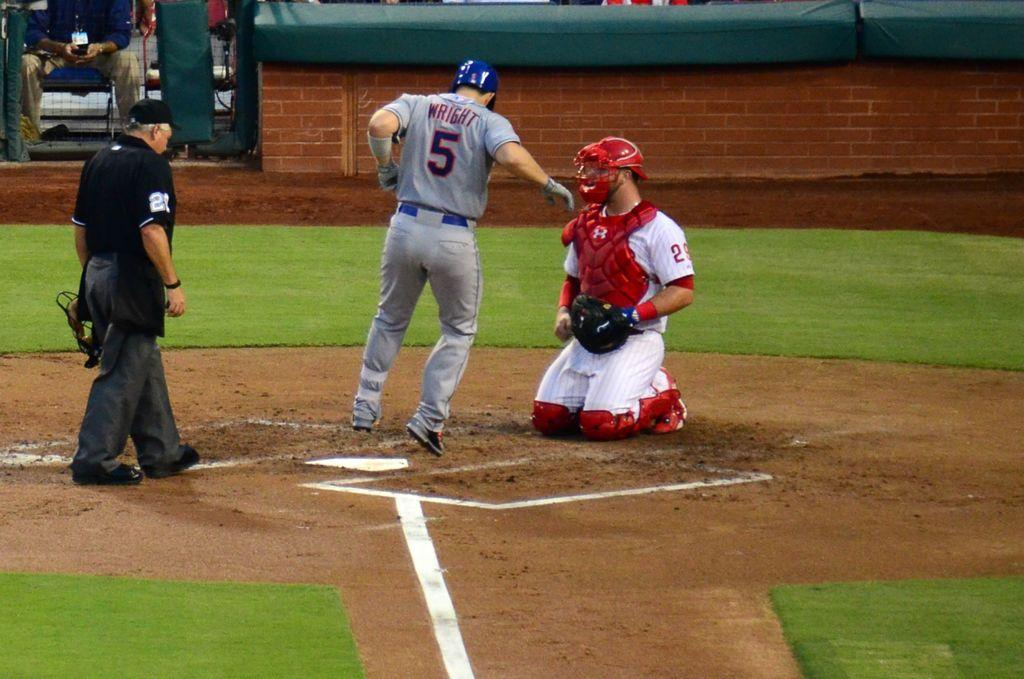Provide a one-sentence caption for the provided image. A baseball player with the name Wright and Number 5 on his back is crossing home plate while the catcher looks on. 